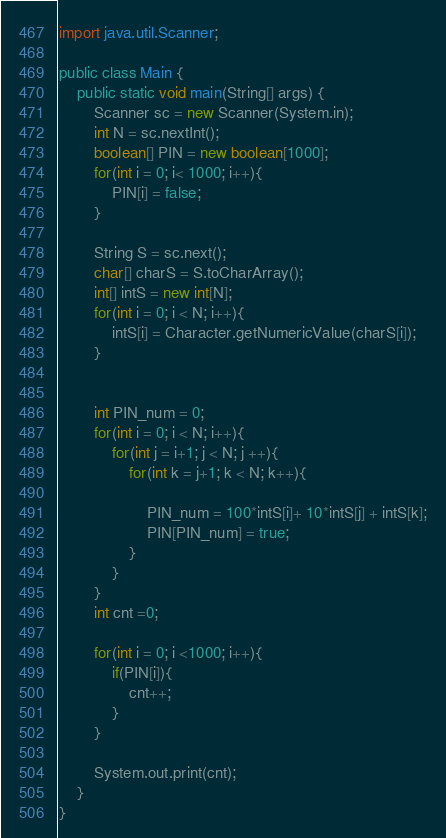Convert code to text. <code><loc_0><loc_0><loc_500><loc_500><_Java_>import java.util.Scanner;

public class Main {
	public static void main(String[] args) {
		Scanner sc = new Scanner(System.in);
		int N = sc.nextInt();
		boolean[] PIN = new boolean[1000];
		for(int i = 0; i< 1000; i++){
			PIN[i] = false;
		}

		String S = sc.next();
		char[] charS = S.toCharArray();
		int[] intS = new int[N];
		for(int i = 0; i < N; i++){
			intS[i] = Character.getNumericValue(charS[i]);
		}


		int PIN_num = 0;
		for(int i = 0; i < N; i++){
			for(int j = i+1; j < N; j ++){
				for(int k = j+1; k < N; k++){

					PIN_num = 100*intS[i]+ 10*intS[j] + intS[k];
					PIN[PIN_num] = true;
				}
			}
		}
		int cnt =0;

		for(int i = 0; i <1000; i++){
			if(PIN[i]){
				cnt++;
			}
		}

		System.out.print(cnt);
	}
}
</code> 